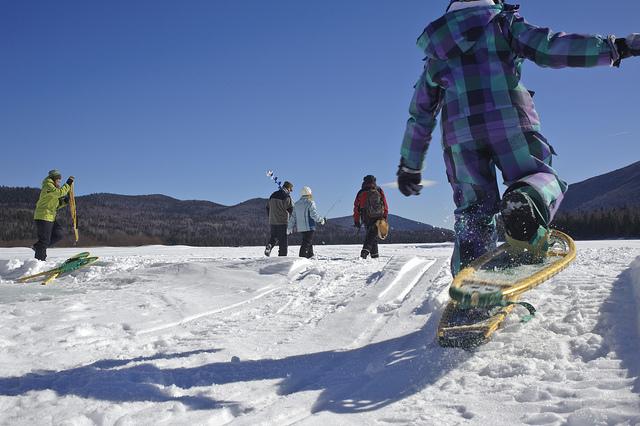Do the mountains have snow on them?
Be succinct. No. What color are the front persons pants?
Be succinct. Blue. What is on the person in plaid's feet?
Be succinct. Snowshoes. Does anyone have a snow suit on?
Answer briefly. Yes. 